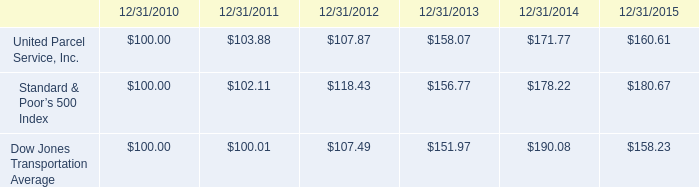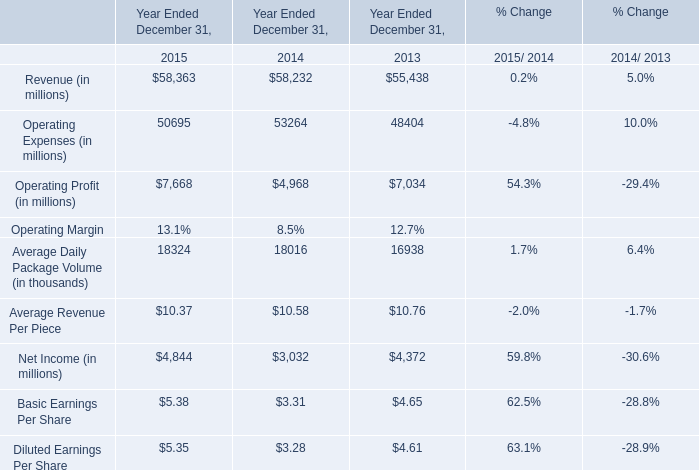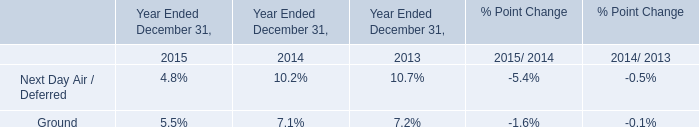Does the value of Operating Expenses (in millions) in 2015 greater than that in 2014? 
Answer: NO. 